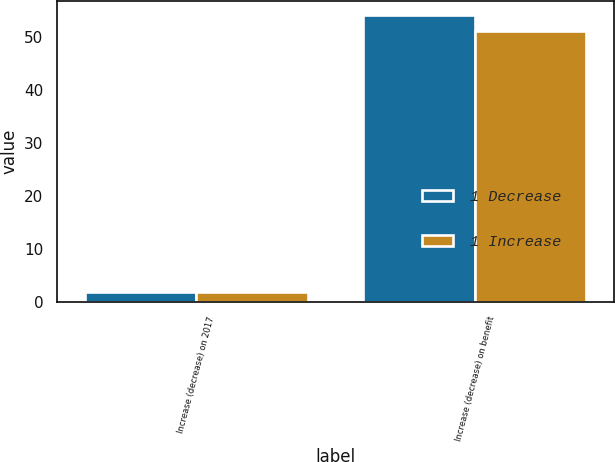Convert chart. <chart><loc_0><loc_0><loc_500><loc_500><stacked_bar_chart><ecel><fcel>Increase (decrease) on 2017<fcel>Increase (decrease) on benefit<nl><fcel>1 Decrease<fcel>2<fcel>54<nl><fcel>1 Increase<fcel>2<fcel>51<nl></chart> 